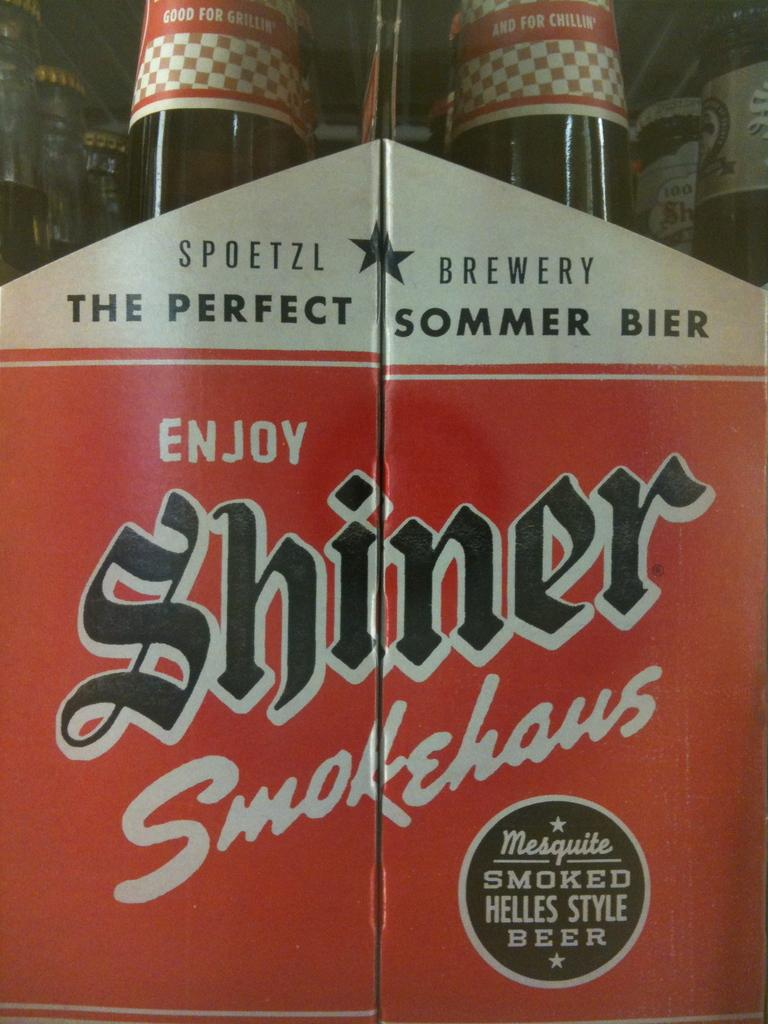<image>
Share a concise interpretation of the image provided. "The perfect sommer bier" is displayed on a box 